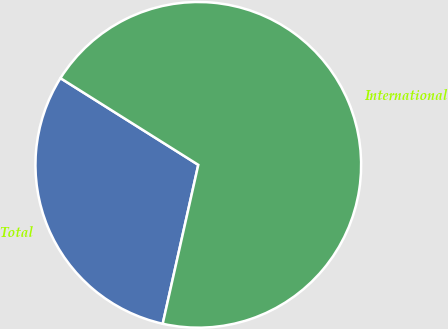Convert chart to OTSL. <chart><loc_0><loc_0><loc_500><loc_500><pie_chart><fcel>Total<fcel>International<nl><fcel>30.43%<fcel>69.57%<nl></chart> 